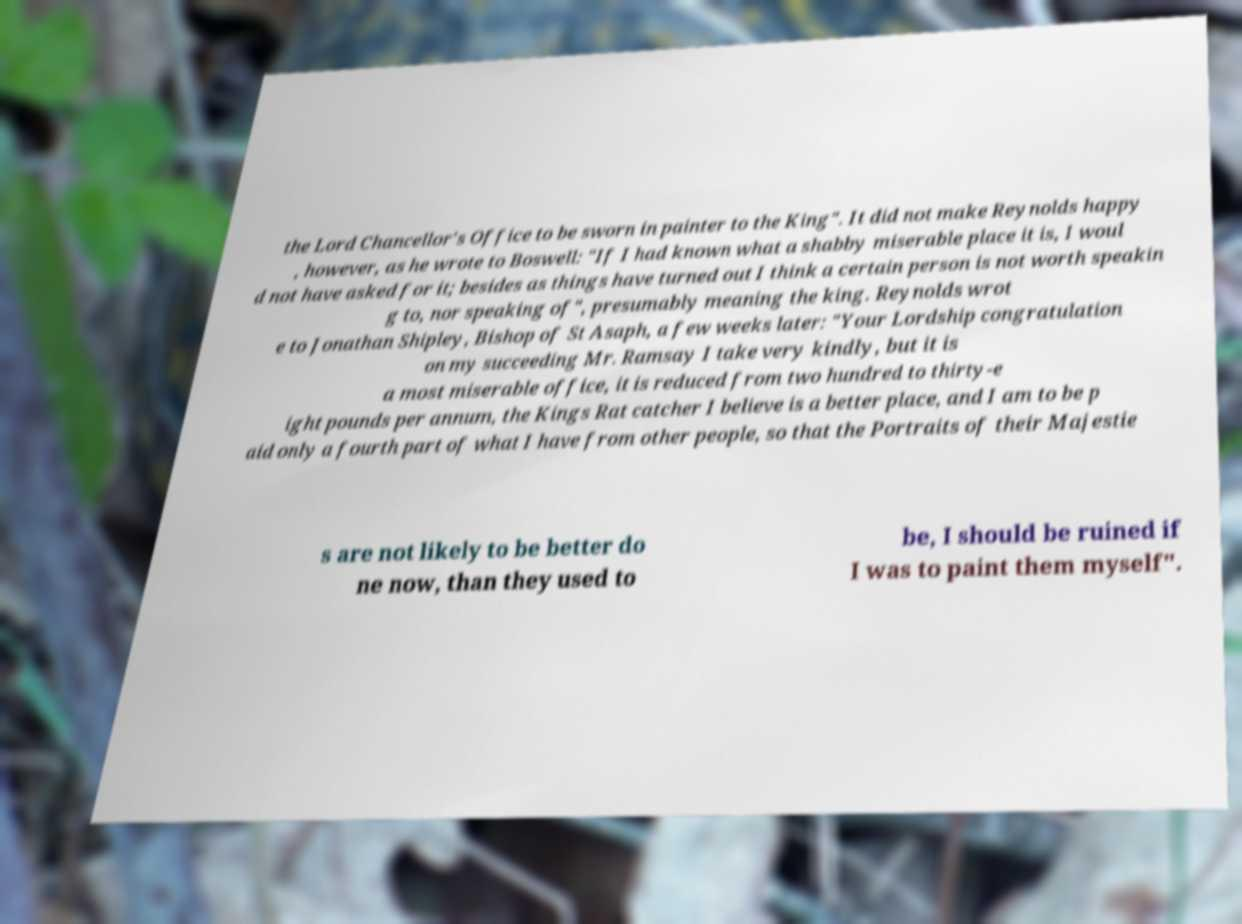Could you assist in decoding the text presented in this image and type it out clearly? the Lord Chancellor's Office to be sworn in painter to the King". It did not make Reynolds happy , however, as he wrote to Boswell: "If I had known what a shabby miserable place it is, I woul d not have asked for it; besides as things have turned out I think a certain person is not worth speakin g to, nor speaking of", presumably meaning the king. Reynolds wrot e to Jonathan Shipley, Bishop of St Asaph, a few weeks later: "Your Lordship congratulation on my succeeding Mr. Ramsay I take very kindly, but it is a most miserable office, it is reduced from two hundred to thirty-e ight pounds per annum, the Kings Rat catcher I believe is a better place, and I am to be p aid only a fourth part of what I have from other people, so that the Portraits of their Majestie s are not likely to be better do ne now, than they used to be, I should be ruined if I was to paint them myself". 